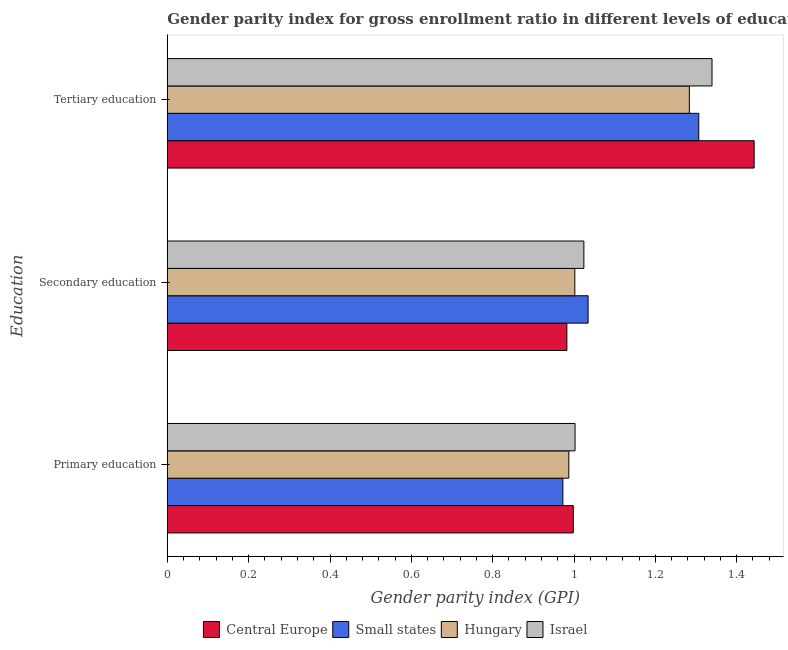How many different coloured bars are there?
Ensure brevity in your answer.  4. How many bars are there on the 2nd tick from the top?
Give a very brief answer. 4. How many bars are there on the 3rd tick from the bottom?
Give a very brief answer. 4. What is the gender parity index in secondary education in Small states?
Give a very brief answer. 1.03. Across all countries, what is the maximum gender parity index in secondary education?
Your response must be concise. 1.03. Across all countries, what is the minimum gender parity index in primary education?
Give a very brief answer. 0.97. In which country was the gender parity index in tertiary education maximum?
Your response must be concise. Central Europe. In which country was the gender parity index in secondary education minimum?
Provide a succinct answer. Central Europe. What is the total gender parity index in primary education in the graph?
Provide a short and direct response. 3.96. What is the difference between the gender parity index in tertiary education in Small states and that in Israel?
Provide a short and direct response. -0.03. What is the difference between the gender parity index in tertiary education in Hungary and the gender parity index in secondary education in Small states?
Provide a succinct answer. 0.25. What is the average gender parity index in secondary education per country?
Keep it short and to the point. 1.01. What is the difference between the gender parity index in primary education and gender parity index in tertiary education in Central Europe?
Provide a short and direct response. -0.44. In how many countries, is the gender parity index in secondary education greater than 0.8400000000000001 ?
Your answer should be compact. 4. What is the ratio of the gender parity index in tertiary education in Hungary to that in Israel?
Keep it short and to the point. 0.96. Is the gender parity index in primary education in Hungary less than that in Central Europe?
Provide a short and direct response. Yes. Is the difference between the gender parity index in tertiary education in Small states and Central Europe greater than the difference between the gender parity index in primary education in Small states and Central Europe?
Keep it short and to the point. No. What is the difference between the highest and the second highest gender parity index in primary education?
Keep it short and to the point. 0. What is the difference between the highest and the lowest gender parity index in secondary education?
Your response must be concise. 0.05. Is the sum of the gender parity index in tertiary education in Central Europe and Small states greater than the maximum gender parity index in primary education across all countries?
Keep it short and to the point. Yes. What does the 4th bar from the top in Secondary education represents?
Keep it short and to the point. Central Europe. What does the 3rd bar from the bottom in Secondary education represents?
Keep it short and to the point. Hungary. How many countries are there in the graph?
Provide a succinct answer. 4. What is the difference between two consecutive major ticks on the X-axis?
Provide a succinct answer. 0.2. Are the values on the major ticks of X-axis written in scientific E-notation?
Offer a very short reply. No. Does the graph contain any zero values?
Provide a short and direct response. No. Does the graph contain grids?
Offer a very short reply. No. Where does the legend appear in the graph?
Offer a very short reply. Bottom center. How many legend labels are there?
Offer a terse response. 4. How are the legend labels stacked?
Your answer should be very brief. Horizontal. What is the title of the graph?
Your answer should be compact. Gender parity index for gross enrollment ratio in different levels of education in 2013. What is the label or title of the X-axis?
Your response must be concise. Gender parity index (GPI). What is the label or title of the Y-axis?
Keep it short and to the point. Education. What is the Gender parity index (GPI) in Central Europe in Primary education?
Give a very brief answer. 1. What is the Gender parity index (GPI) of Small states in Primary education?
Ensure brevity in your answer.  0.97. What is the Gender parity index (GPI) of Hungary in Primary education?
Your answer should be compact. 0.99. What is the Gender parity index (GPI) in Israel in Primary education?
Provide a short and direct response. 1. What is the Gender parity index (GPI) of Central Europe in Secondary education?
Offer a very short reply. 0.98. What is the Gender parity index (GPI) in Small states in Secondary education?
Your answer should be very brief. 1.03. What is the Gender parity index (GPI) in Hungary in Secondary education?
Your answer should be compact. 1. What is the Gender parity index (GPI) of Israel in Secondary education?
Keep it short and to the point. 1.02. What is the Gender parity index (GPI) in Central Europe in Tertiary education?
Ensure brevity in your answer.  1.44. What is the Gender parity index (GPI) in Small states in Tertiary education?
Ensure brevity in your answer.  1.31. What is the Gender parity index (GPI) in Hungary in Tertiary education?
Make the answer very short. 1.28. What is the Gender parity index (GPI) in Israel in Tertiary education?
Ensure brevity in your answer.  1.34. Across all Education, what is the maximum Gender parity index (GPI) in Central Europe?
Offer a very short reply. 1.44. Across all Education, what is the maximum Gender parity index (GPI) of Small states?
Offer a very short reply. 1.31. Across all Education, what is the maximum Gender parity index (GPI) of Hungary?
Offer a terse response. 1.28. Across all Education, what is the maximum Gender parity index (GPI) of Israel?
Your response must be concise. 1.34. Across all Education, what is the minimum Gender parity index (GPI) of Central Europe?
Your answer should be very brief. 0.98. Across all Education, what is the minimum Gender parity index (GPI) of Small states?
Provide a succinct answer. 0.97. Across all Education, what is the minimum Gender parity index (GPI) of Hungary?
Your answer should be very brief. 0.99. Across all Education, what is the minimum Gender parity index (GPI) of Israel?
Provide a succinct answer. 1. What is the total Gender parity index (GPI) of Central Europe in the graph?
Your answer should be very brief. 3.42. What is the total Gender parity index (GPI) of Small states in the graph?
Make the answer very short. 3.31. What is the total Gender parity index (GPI) in Hungary in the graph?
Your answer should be compact. 3.27. What is the total Gender parity index (GPI) of Israel in the graph?
Offer a very short reply. 3.37. What is the difference between the Gender parity index (GPI) in Central Europe in Primary education and that in Secondary education?
Your answer should be compact. 0.02. What is the difference between the Gender parity index (GPI) of Small states in Primary education and that in Secondary education?
Your answer should be very brief. -0.06. What is the difference between the Gender parity index (GPI) in Hungary in Primary education and that in Secondary education?
Ensure brevity in your answer.  -0.01. What is the difference between the Gender parity index (GPI) of Israel in Primary education and that in Secondary education?
Your answer should be compact. -0.02. What is the difference between the Gender parity index (GPI) in Central Europe in Primary education and that in Tertiary education?
Make the answer very short. -0.44. What is the difference between the Gender parity index (GPI) of Small states in Primary education and that in Tertiary education?
Your answer should be compact. -0.33. What is the difference between the Gender parity index (GPI) in Hungary in Primary education and that in Tertiary education?
Provide a succinct answer. -0.3. What is the difference between the Gender parity index (GPI) of Israel in Primary education and that in Tertiary education?
Provide a short and direct response. -0.34. What is the difference between the Gender parity index (GPI) in Central Europe in Secondary education and that in Tertiary education?
Keep it short and to the point. -0.46. What is the difference between the Gender parity index (GPI) of Small states in Secondary education and that in Tertiary education?
Make the answer very short. -0.27. What is the difference between the Gender parity index (GPI) of Hungary in Secondary education and that in Tertiary education?
Your response must be concise. -0.28. What is the difference between the Gender parity index (GPI) in Israel in Secondary education and that in Tertiary education?
Offer a terse response. -0.32. What is the difference between the Gender parity index (GPI) of Central Europe in Primary education and the Gender parity index (GPI) of Small states in Secondary education?
Keep it short and to the point. -0.04. What is the difference between the Gender parity index (GPI) of Central Europe in Primary education and the Gender parity index (GPI) of Hungary in Secondary education?
Ensure brevity in your answer.  -0. What is the difference between the Gender parity index (GPI) of Central Europe in Primary education and the Gender parity index (GPI) of Israel in Secondary education?
Offer a very short reply. -0.03. What is the difference between the Gender parity index (GPI) of Small states in Primary education and the Gender parity index (GPI) of Hungary in Secondary education?
Offer a very short reply. -0.03. What is the difference between the Gender parity index (GPI) in Small states in Primary education and the Gender parity index (GPI) in Israel in Secondary education?
Ensure brevity in your answer.  -0.05. What is the difference between the Gender parity index (GPI) in Hungary in Primary education and the Gender parity index (GPI) in Israel in Secondary education?
Provide a short and direct response. -0.04. What is the difference between the Gender parity index (GPI) in Central Europe in Primary education and the Gender parity index (GPI) in Small states in Tertiary education?
Keep it short and to the point. -0.31. What is the difference between the Gender parity index (GPI) in Central Europe in Primary education and the Gender parity index (GPI) in Hungary in Tertiary education?
Offer a very short reply. -0.29. What is the difference between the Gender parity index (GPI) of Central Europe in Primary education and the Gender parity index (GPI) of Israel in Tertiary education?
Give a very brief answer. -0.34. What is the difference between the Gender parity index (GPI) in Small states in Primary education and the Gender parity index (GPI) in Hungary in Tertiary education?
Provide a short and direct response. -0.31. What is the difference between the Gender parity index (GPI) of Small states in Primary education and the Gender parity index (GPI) of Israel in Tertiary education?
Make the answer very short. -0.37. What is the difference between the Gender parity index (GPI) of Hungary in Primary education and the Gender parity index (GPI) of Israel in Tertiary education?
Your answer should be compact. -0.35. What is the difference between the Gender parity index (GPI) of Central Europe in Secondary education and the Gender parity index (GPI) of Small states in Tertiary education?
Your answer should be compact. -0.32. What is the difference between the Gender parity index (GPI) of Central Europe in Secondary education and the Gender parity index (GPI) of Hungary in Tertiary education?
Provide a succinct answer. -0.3. What is the difference between the Gender parity index (GPI) in Central Europe in Secondary education and the Gender parity index (GPI) in Israel in Tertiary education?
Make the answer very short. -0.36. What is the difference between the Gender parity index (GPI) in Small states in Secondary education and the Gender parity index (GPI) in Hungary in Tertiary education?
Provide a short and direct response. -0.25. What is the difference between the Gender parity index (GPI) in Small states in Secondary education and the Gender parity index (GPI) in Israel in Tertiary education?
Offer a very short reply. -0.3. What is the difference between the Gender parity index (GPI) of Hungary in Secondary education and the Gender parity index (GPI) of Israel in Tertiary education?
Provide a succinct answer. -0.34. What is the average Gender parity index (GPI) of Central Europe per Education?
Your answer should be compact. 1.14. What is the average Gender parity index (GPI) in Small states per Education?
Provide a short and direct response. 1.1. What is the average Gender parity index (GPI) of Hungary per Education?
Ensure brevity in your answer.  1.09. What is the average Gender parity index (GPI) of Israel per Education?
Offer a very short reply. 1.12. What is the difference between the Gender parity index (GPI) of Central Europe and Gender parity index (GPI) of Small states in Primary education?
Give a very brief answer. 0.03. What is the difference between the Gender parity index (GPI) in Central Europe and Gender parity index (GPI) in Hungary in Primary education?
Your answer should be very brief. 0.01. What is the difference between the Gender parity index (GPI) in Central Europe and Gender parity index (GPI) in Israel in Primary education?
Your answer should be very brief. -0. What is the difference between the Gender parity index (GPI) of Small states and Gender parity index (GPI) of Hungary in Primary education?
Offer a very short reply. -0.01. What is the difference between the Gender parity index (GPI) in Small states and Gender parity index (GPI) in Israel in Primary education?
Offer a very short reply. -0.03. What is the difference between the Gender parity index (GPI) of Hungary and Gender parity index (GPI) of Israel in Primary education?
Your answer should be very brief. -0.02. What is the difference between the Gender parity index (GPI) in Central Europe and Gender parity index (GPI) in Small states in Secondary education?
Your answer should be compact. -0.05. What is the difference between the Gender parity index (GPI) of Central Europe and Gender parity index (GPI) of Hungary in Secondary education?
Provide a short and direct response. -0.02. What is the difference between the Gender parity index (GPI) in Central Europe and Gender parity index (GPI) in Israel in Secondary education?
Your response must be concise. -0.04. What is the difference between the Gender parity index (GPI) in Small states and Gender parity index (GPI) in Hungary in Secondary education?
Your response must be concise. 0.03. What is the difference between the Gender parity index (GPI) of Small states and Gender parity index (GPI) of Israel in Secondary education?
Make the answer very short. 0.01. What is the difference between the Gender parity index (GPI) of Hungary and Gender parity index (GPI) of Israel in Secondary education?
Provide a short and direct response. -0.02. What is the difference between the Gender parity index (GPI) in Central Europe and Gender parity index (GPI) in Small states in Tertiary education?
Your answer should be very brief. 0.14. What is the difference between the Gender parity index (GPI) of Central Europe and Gender parity index (GPI) of Hungary in Tertiary education?
Your response must be concise. 0.16. What is the difference between the Gender parity index (GPI) of Central Europe and Gender parity index (GPI) of Israel in Tertiary education?
Give a very brief answer. 0.1. What is the difference between the Gender parity index (GPI) in Small states and Gender parity index (GPI) in Hungary in Tertiary education?
Your answer should be very brief. 0.02. What is the difference between the Gender parity index (GPI) of Small states and Gender parity index (GPI) of Israel in Tertiary education?
Offer a very short reply. -0.03. What is the difference between the Gender parity index (GPI) of Hungary and Gender parity index (GPI) of Israel in Tertiary education?
Keep it short and to the point. -0.06. What is the ratio of the Gender parity index (GPI) in Central Europe in Primary education to that in Secondary education?
Your response must be concise. 1.02. What is the ratio of the Gender parity index (GPI) in Small states in Primary education to that in Secondary education?
Provide a succinct answer. 0.94. What is the ratio of the Gender parity index (GPI) of Israel in Primary education to that in Secondary education?
Offer a terse response. 0.98. What is the ratio of the Gender parity index (GPI) in Central Europe in Primary education to that in Tertiary education?
Provide a short and direct response. 0.69. What is the ratio of the Gender parity index (GPI) in Small states in Primary education to that in Tertiary education?
Offer a very short reply. 0.74. What is the ratio of the Gender parity index (GPI) in Hungary in Primary education to that in Tertiary education?
Offer a terse response. 0.77. What is the ratio of the Gender parity index (GPI) of Israel in Primary education to that in Tertiary education?
Your answer should be very brief. 0.75. What is the ratio of the Gender parity index (GPI) in Central Europe in Secondary education to that in Tertiary education?
Keep it short and to the point. 0.68. What is the ratio of the Gender parity index (GPI) in Small states in Secondary education to that in Tertiary education?
Provide a succinct answer. 0.79. What is the ratio of the Gender parity index (GPI) in Hungary in Secondary education to that in Tertiary education?
Ensure brevity in your answer.  0.78. What is the ratio of the Gender parity index (GPI) in Israel in Secondary education to that in Tertiary education?
Ensure brevity in your answer.  0.76. What is the difference between the highest and the second highest Gender parity index (GPI) in Central Europe?
Offer a terse response. 0.44. What is the difference between the highest and the second highest Gender parity index (GPI) of Small states?
Your answer should be very brief. 0.27. What is the difference between the highest and the second highest Gender parity index (GPI) in Hungary?
Provide a short and direct response. 0.28. What is the difference between the highest and the second highest Gender parity index (GPI) in Israel?
Provide a succinct answer. 0.32. What is the difference between the highest and the lowest Gender parity index (GPI) in Central Europe?
Provide a succinct answer. 0.46. What is the difference between the highest and the lowest Gender parity index (GPI) of Small states?
Your response must be concise. 0.33. What is the difference between the highest and the lowest Gender parity index (GPI) of Hungary?
Offer a terse response. 0.3. What is the difference between the highest and the lowest Gender parity index (GPI) of Israel?
Offer a very short reply. 0.34. 